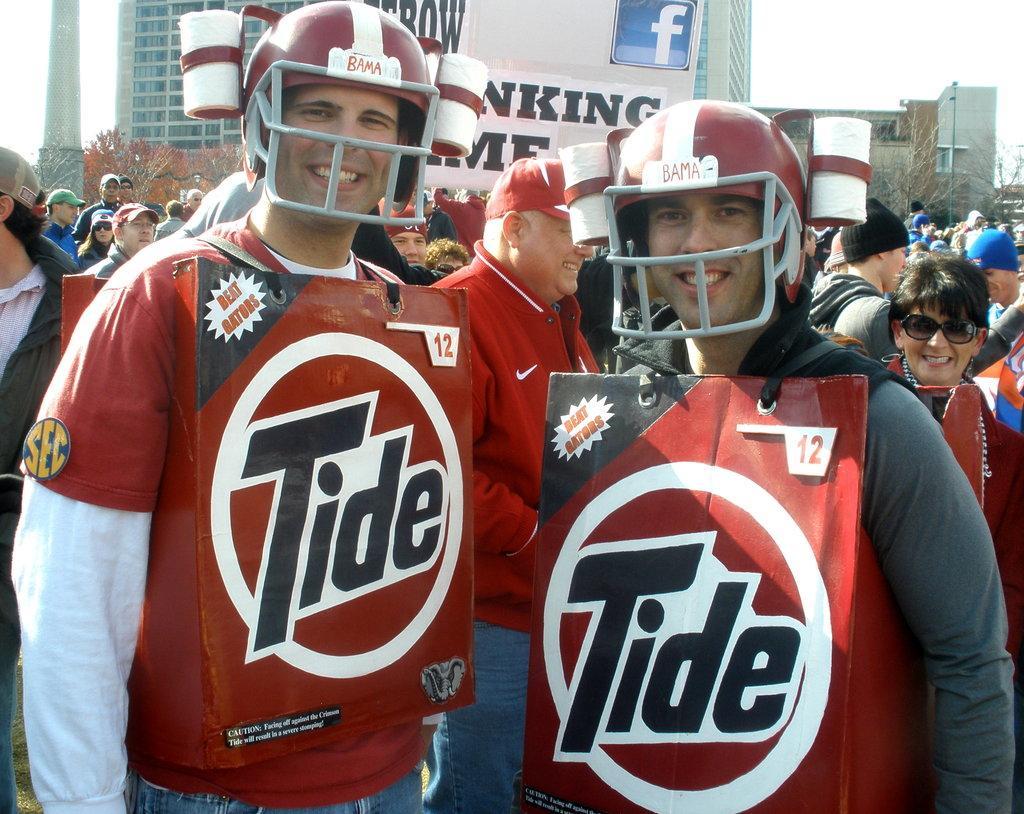Describe this image in one or two sentences. In the foreground of this image, there are two men having posters to their body and helmets to their heads with smile on their faces. In the background, there are people, trees, buildings, banners and the sky. 